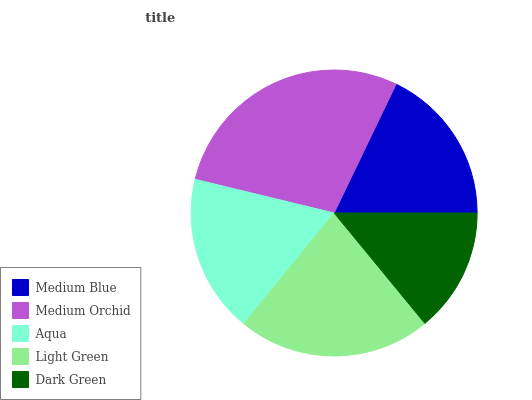Is Dark Green the minimum?
Answer yes or no. Yes. Is Medium Orchid the maximum?
Answer yes or no. Yes. Is Aqua the minimum?
Answer yes or no. No. Is Aqua the maximum?
Answer yes or no. No. Is Medium Orchid greater than Aqua?
Answer yes or no. Yes. Is Aqua less than Medium Orchid?
Answer yes or no. Yes. Is Aqua greater than Medium Orchid?
Answer yes or no. No. Is Medium Orchid less than Aqua?
Answer yes or no. No. Is Aqua the high median?
Answer yes or no. Yes. Is Aqua the low median?
Answer yes or no. Yes. Is Medium Blue the high median?
Answer yes or no. No. Is Light Green the low median?
Answer yes or no. No. 